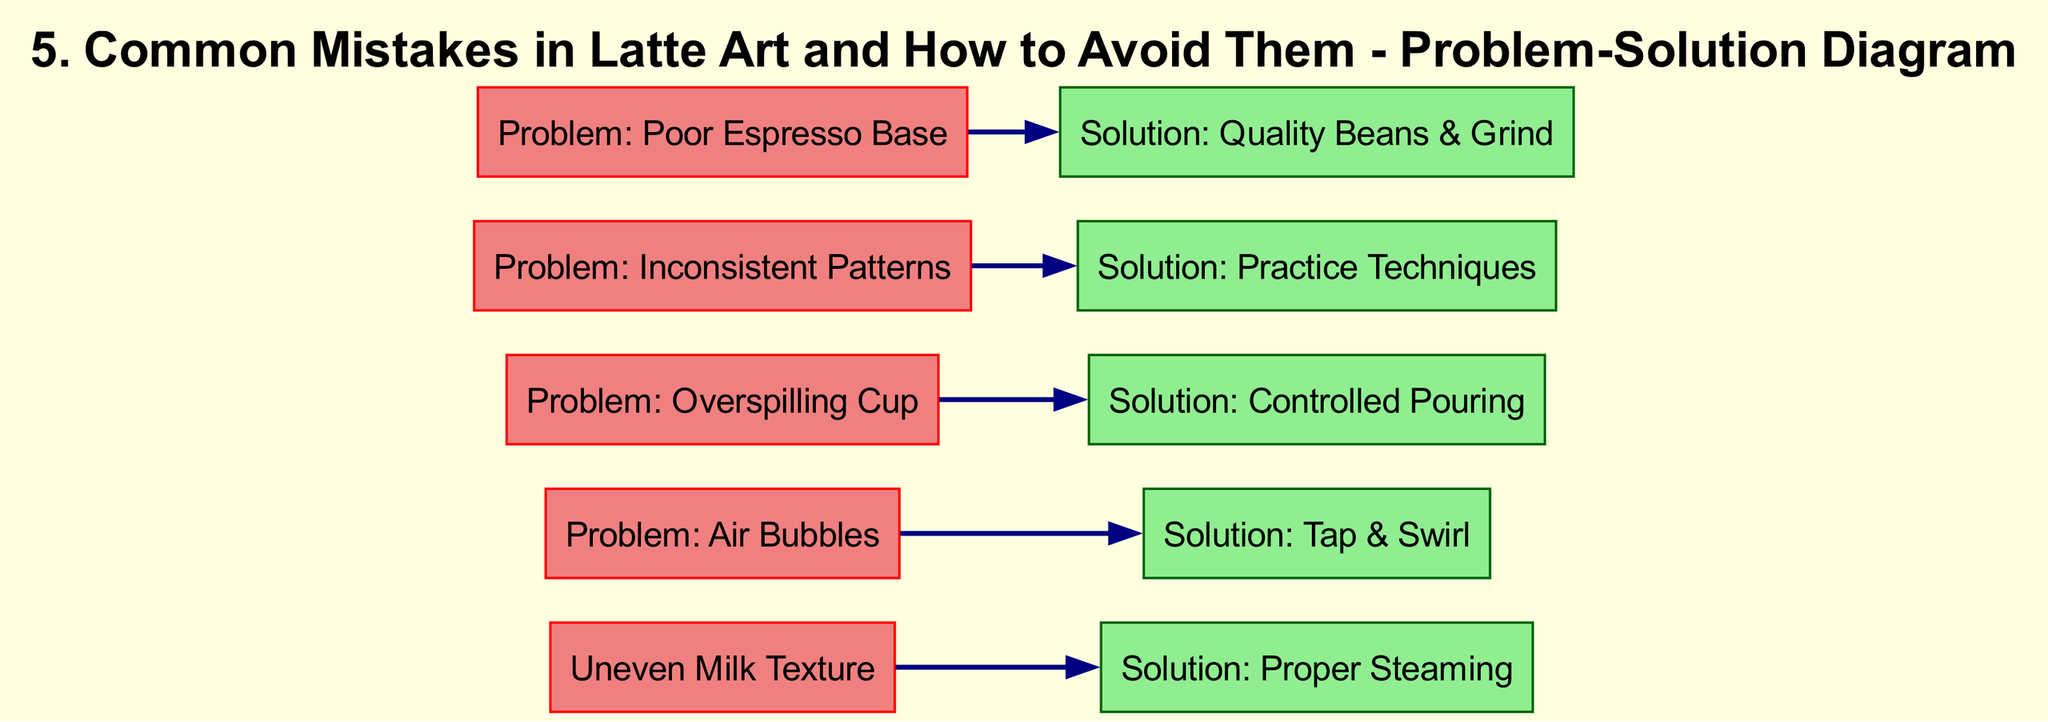What is the first problem listed in the diagram? The first node in the diagram lists "Uneven Milk Texture" as the first problem.
Answer: Uneven Milk Texture How many solutions are presented in the diagram? There are five solutions provided, each corresponding to a problem listed.
Answer: Five What problem is associated with "Tap & Swirl"? "Tap & Swirl" is the solution associated with the problem "Air Bubbles" as shown by the connecting edge.
Answer: Air Bubbles Which problem relates to the solution "Quality Beans & Grind"? The problem "Poor Espresso Base" is linked to the solution "Quality Beans & Grind" through the directed edge.
Answer: Poor Espresso Base What is the connection between "Inconsistent Patterns" and "Practice Techniques"? "Inconsistent Patterns" is a problem that is addressed by the solution "Practice Techniques," indicating a direct relationship in the diagram.
Answer: Practice Techniques How many problems are listed in total? There are five problems listed within the diagram that define common issues in latte art.
Answer: Five Which solution follows the problem "Overspilling Cup"? The solution that follows "Overspilling Cup" is "Controlled Pouring," highlighting a method to address the problem.
Answer: Controlled Pouring What color are the problem nodes in the diagram? The problem nodes are colored light coral, distinguishing them from solution nodes that are light green.
Answer: Light Coral Which node has a direct path to "Proper Steaming"? The node for "Uneven Milk Texture" connects directly to "Proper Steaming," indicating the solution to this particular problem.
Answer: Uneven Milk Texture 